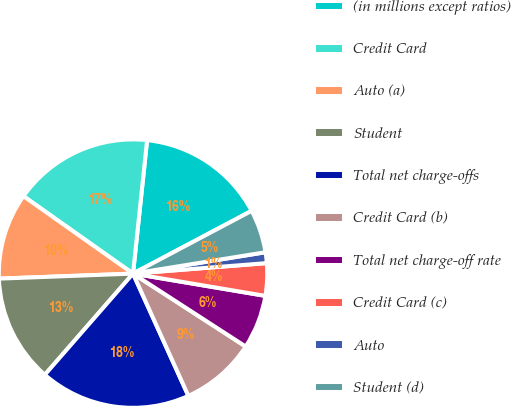Convert chart. <chart><loc_0><loc_0><loc_500><loc_500><pie_chart><fcel>(in millions except ratios)<fcel>Credit Card<fcel>Auto (a)<fcel>Student<fcel>Total net charge-offs<fcel>Credit Card (b)<fcel>Total net charge-off rate<fcel>Credit Card (c)<fcel>Auto<fcel>Student (d)<nl><fcel>15.58%<fcel>16.88%<fcel>10.39%<fcel>12.99%<fcel>18.18%<fcel>9.09%<fcel>6.49%<fcel>3.9%<fcel>1.3%<fcel>5.2%<nl></chart> 